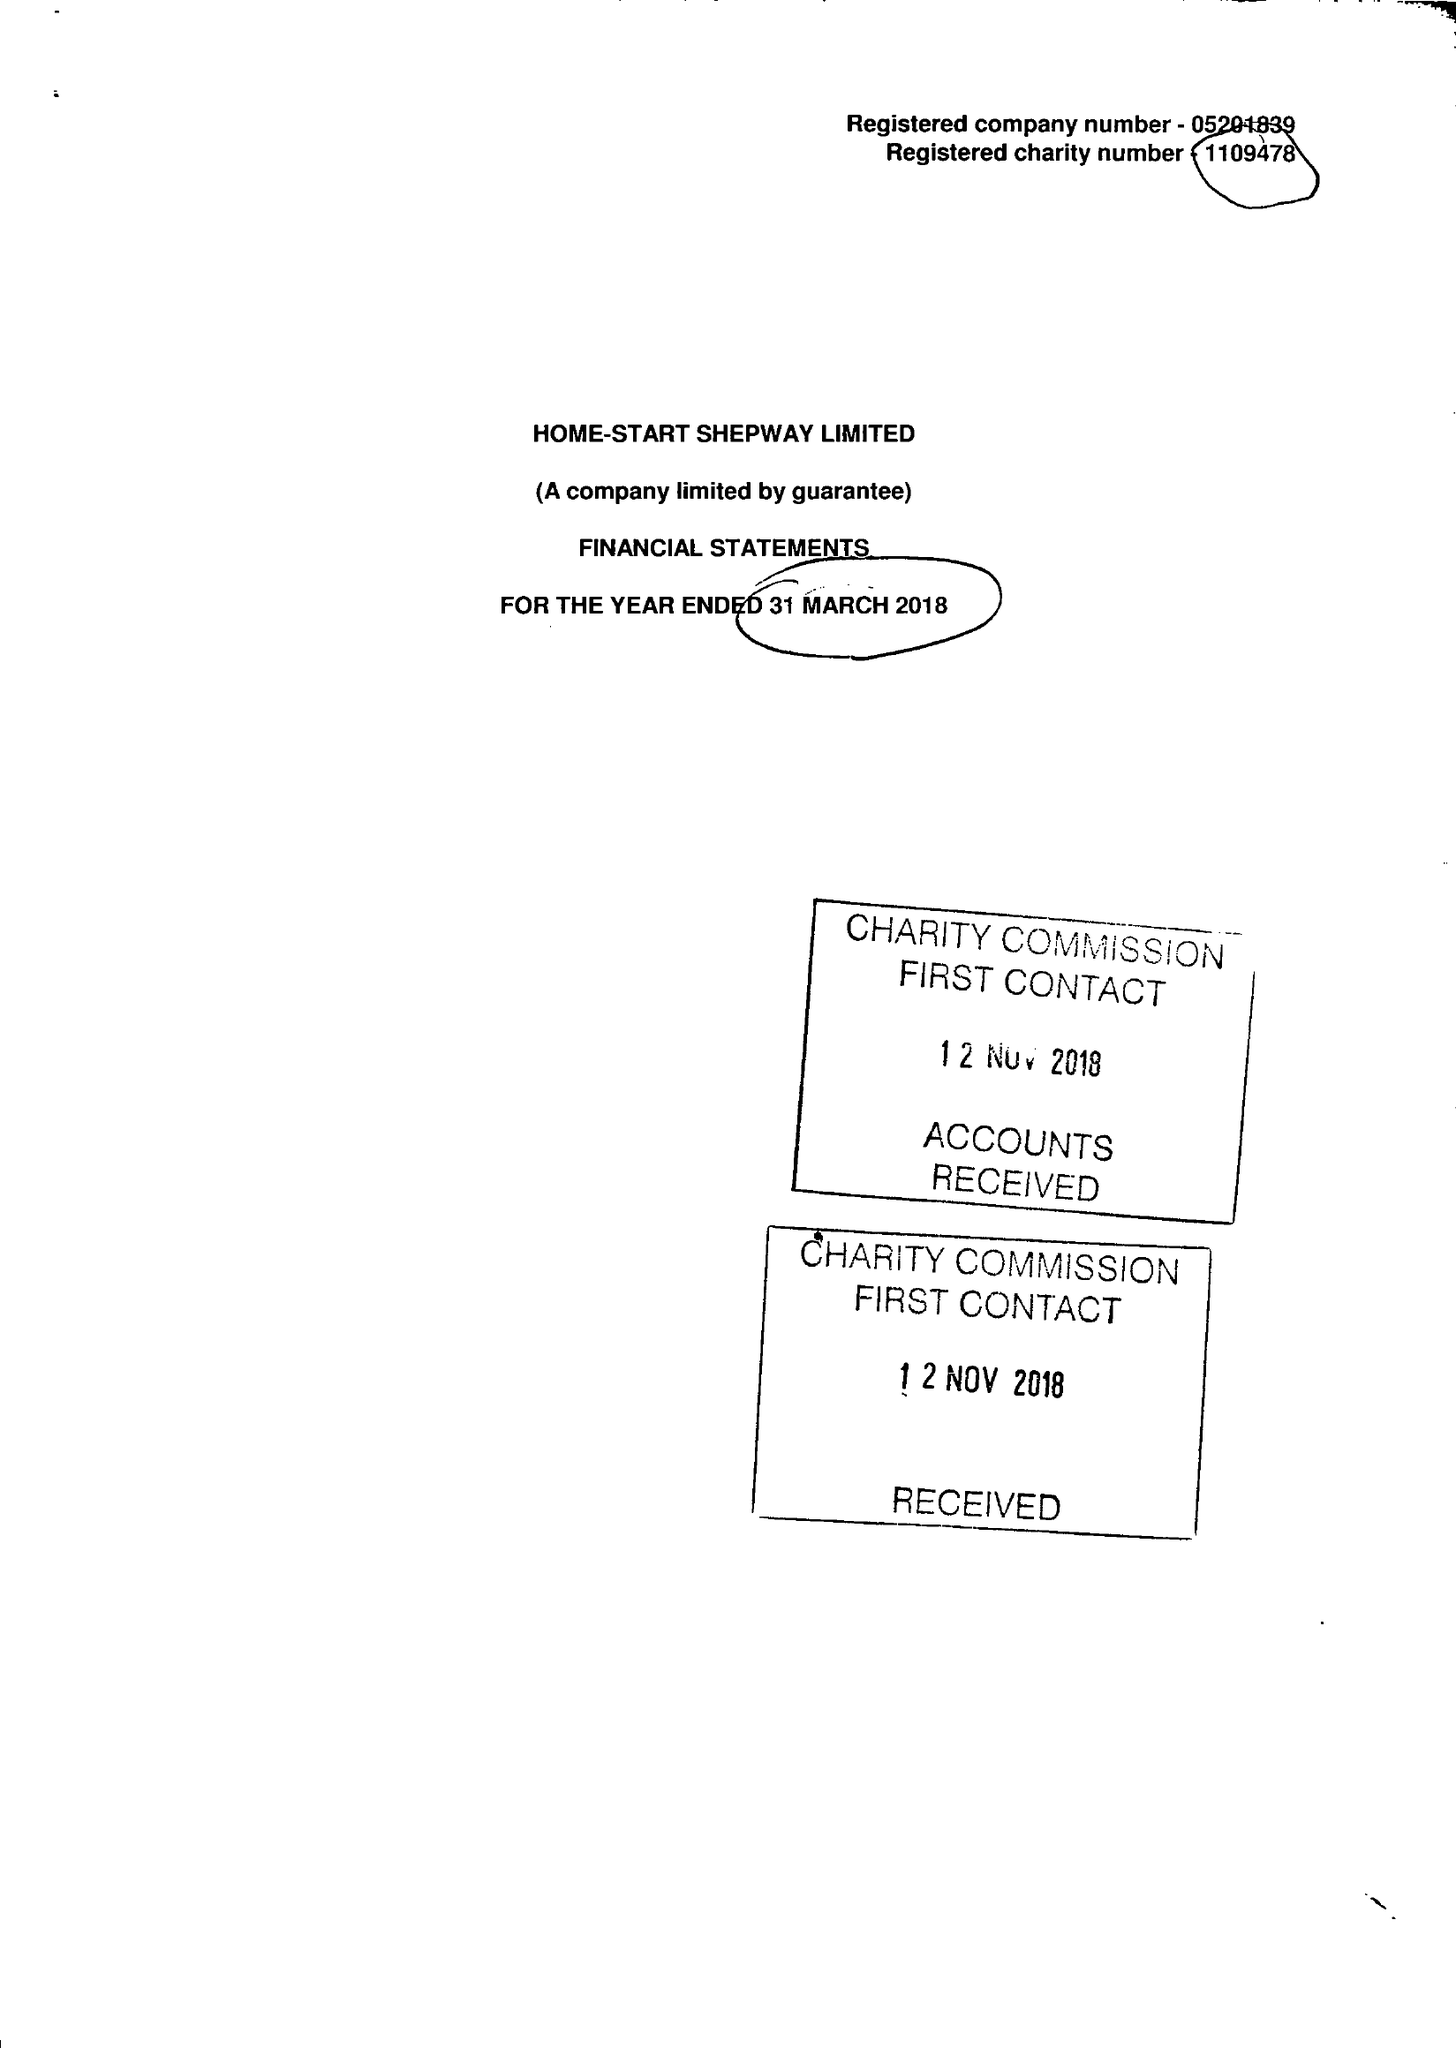What is the value for the report_date?
Answer the question using a single word or phrase. 2018-03-31 